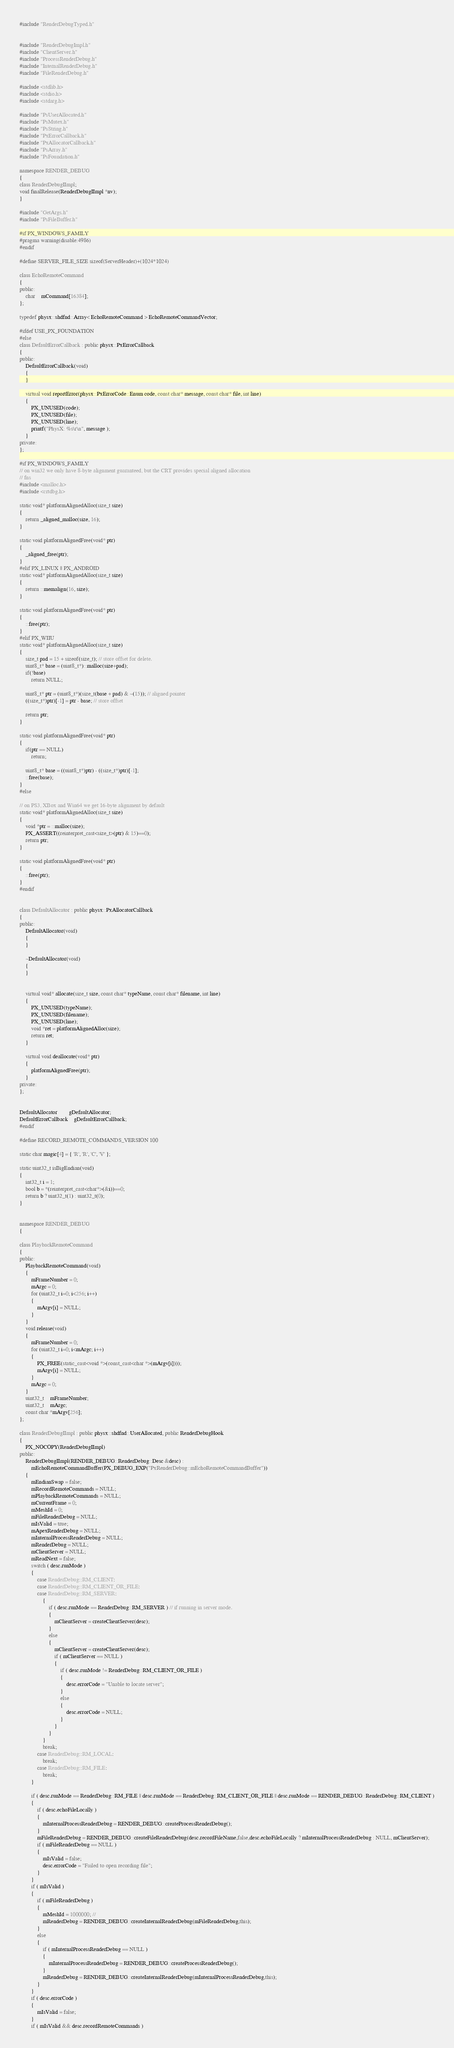<code> <loc_0><loc_0><loc_500><loc_500><_C++_>#include "RenderDebugTyped.h"


#include "RenderDebugImpl.h"
#include "ClientServer.h"
#include "ProcessRenderDebug.h"
#include "InternalRenderDebug.h"
#include "FileRenderDebug.h"

#include <stdlib.h>
#include <stdio.h>
#include <stdarg.h>

#include "PsUserAllocated.h"
#include "PsMutex.h"
#include "PsString.h"
#include "PxErrorCallback.h"
#include "PxAllocatorCallback.h"
#include "PsArray.h"
#include "PsFoundation.h"

namespace RENDER_DEBUG
{
class RenderDebugIImpl;
void finalRelease(RenderDebugIImpl *nv);
}

#include "GetArgs.h"
#include "PsFileBuffer.h"

#if PX_WINDOWS_FAMILY
#pragma warning(disable:4986)
#endif

#define SERVER_FILE_SIZE sizeof(ServerHeader)+(1024*1024)

class EchoRemoteCommand
{
public:
	char	mCommand[16384];
};

typedef physx::shdfnd::Array< EchoRemoteCommand > EchoRemoteCommandVector;

#ifdef USE_PX_FOUNDATION
#else
class DefaultErrorCallback : public physx::PxErrorCallback
{
public:
	DefaultErrorCallback(void)
	{
	}

	virtual void reportError(physx::PxErrorCode::Enum code, const char* message, const char* file, int line)
	{
		PX_UNUSED(code);
		PX_UNUSED(file);
		PX_UNUSED(line);
		printf("PhysX: %s\r\n", message );
	}
private:
};

#if PX_WINDOWS_FAMILY
// on win32 we only have 8-byte alignment guaranteed, but the CRT provides special aligned allocation
// fns
#include <malloc.h>
#include <crtdbg.h>

static void* platformAlignedAlloc(size_t size)
{
	return _aligned_malloc(size, 16);	
}

static void platformAlignedFree(void* ptr)
{
	_aligned_free(ptr);
}
#elif PX_LINUX || PX_ANDROID
static void* platformAlignedAlloc(size_t size)
{
	return ::memalign(16, size);
}

static void platformAlignedFree(void* ptr)
{
	::free(ptr);
}
#elif PX_WIIU
static void* platformAlignedAlloc(size_t size)
{
	size_t pad = 15 + sizeof(size_t); // store offset for delete.
	uint8_t* base = (uint8_t*)::malloc(size+pad);
	if(!base)
		return NULL;

	uint8_t* ptr = (uint8_t*)(size_t(base + pad) & ~(15)); // aligned pointer
	((size_t*)ptr)[-1] = ptr - base; // store offset

	return ptr;
}

static void platformAlignedFree(void* ptr)
{
	if(ptr == NULL)
		return;

	uint8_t* base = ((uint8_t*)ptr) - ((size_t*)ptr)[-1];
	::free(base);
}
#else

// on PS3, XBox and Win64 we get 16-byte alignment by default
static void* platformAlignedAlloc(size_t size)
{
	void *ptr = ::malloc(size);	
	PX_ASSERT((reinterpret_cast<size_t>(ptr) & 15)==0);
	return ptr;
}

static void platformAlignedFree(void* ptr)
{
	::free(ptr);			
}
#endif


class DefaultAllocator : public physx::PxAllocatorCallback
{
public:
	DefaultAllocator(void)
	{
	}

	~DefaultAllocator(void)
	{
	}


	virtual void* allocate(size_t size, const char* typeName, const char* filename, int line)
	{
		PX_UNUSED(typeName);
		PX_UNUSED(filename);
		PX_UNUSED(line);
		void *ret = platformAlignedAlloc(size);
		return ret;
	}

	virtual void deallocate(void* ptr)
	{
		platformAlignedFree(ptr);
	}
private:
};


DefaultAllocator		gDefaultAllocator;
DefaultErrorCallback	gDefaultErrorCallback;
#endif

#define RECORD_REMOTE_COMMANDS_VERSION 100

static char magic[4] = { 'R', 'R', 'C', 'V' };

static uint32_t isBigEndian(void)
{
	int32_t i = 1;
	bool b = *(reinterpret_cast<char*>(&i))==0;
	return b ? uint32_t(1) : uint32_t(0);
}


namespace RENDER_DEBUG
{

class PlaybackRemoteCommand
{
public:
	PlaybackRemoteCommand(void)
	{
		mFrameNumber = 0;
		mArgc = 0;
		for (uint32_t i=0; i<256; i++)
		{
			mArgv[i] = NULL;
		}
	}
	void release(void)
	{
		mFrameNumber = 0;
		for (uint32_t i=0; i<mArgc; i++)
		{
			PX_FREE(static_cast<void *>(const_cast<char *>(mArgv[i])));
			mArgv[i] = NULL;
		}
		mArgc = 0;
	}
	uint32_t	mFrameNumber;
	uint32_t	mArgc;
	const char *mArgv[256];
};

class RenderDebugIImpl : public physx::shdfnd::UserAllocated, public RenderDebugHook
{
	PX_NOCOPY(RenderDebugIImpl)
public:
	RenderDebugIImpl(RENDER_DEBUG::RenderDebug::Desc &desc) :
		mEchoRemoteCommandBuffer(PX_DEBUG_EXP("PxRenderDebug::mEchoRemoteCommandBuffer"))
	{
		mEndianSwap = false;
		mRecordRemoteCommands = NULL;
		mPlaybackRemoteCommands = NULL;
		mCurrentFrame = 0;
		mMeshId = 0;
		mFileRenderDebug = NULL;
		mIsValid = true;
		mApexRenderDebug = NULL;
		mInternalProcessRenderDebug = NULL;
		mRenderDebug = NULL;
		mClientServer = NULL;
		mReadNext = false;
		switch ( desc.runMode )
		{
			case RenderDebug::RM_CLIENT:
			case RenderDebug::RM_CLIENT_OR_FILE:
			case RenderDebug::RM_SERVER:
				{
					if ( desc.runMode == RenderDebug::RM_SERVER ) // if running in server mode.
					{
						mClientServer = createClientServer(desc);
					}
					else 
					{
						mClientServer = createClientServer(desc);
						if ( mClientServer == NULL )
						{
							if ( desc.runMode != RenderDebug::RM_CLIENT_OR_FILE )
							{
								desc.errorCode = "Unable to locate server";
							}
							else
							{
								desc.errorCode = NULL;
							}
						}
					}
				}
				break;
			case RenderDebug::RM_LOCAL:
				break;
			case RenderDebug::RM_FILE:
				break;
		}

		if ( desc.runMode == RenderDebug::RM_FILE || desc.runMode == RenderDebug::RM_CLIENT_OR_FILE || desc.runMode == RENDER_DEBUG::RenderDebug::RM_CLIENT )
		{
			if ( desc.echoFileLocally )
			{
				mInternalProcessRenderDebug = RENDER_DEBUG::createProcessRenderDebug();
			}
			mFileRenderDebug = RENDER_DEBUG::createFileRenderDebug(desc.recordFileName,false,desc.echoFileLocally ? mInternalProcessRenderDebug : NULL, mClientServer);
			if ( mFileRenderDebug == NULL )
			{
				mIsValid = false;
				desc.errorCode = "Failed to open recording file";
			}
		}
		if ( mIsValid )
		{
			if ( mFileRenderDebug )
			{
				mMeshId = 1000000; // 
				mRenderDebug = RENDER_DEBUG::createInternalRenderDebug(mFileRenderDebug,this);
			}
			else
			{
				if ( mInternalProcessRenderDebug == NULL )
				{
					mInternalProcessRenderDebug = RENDER_DEBUG::createProcessRenderDebug();
				}
				mRenderDebug = RENDER_DEBUG::createInternalRenderDebug(mInternalProcessRenderDebug,this);
			}
		}
		if ( desc.errorCode )
		{
			mIsValid = false;
		}
		if ( mIsValid && desc.recordRemoteCommands )</code> 